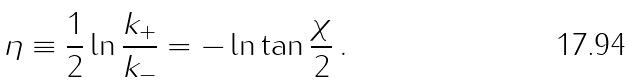Convert formula to latex. <formula><loc_0><loc_0><loc_500><loc_500>\eta \equiv \frac { 1 } { 2 } \ln \frac { k _ { + } } { k _ { - } } = - \ln \tan \frac { \chi } { 2 } \, .</formula> 